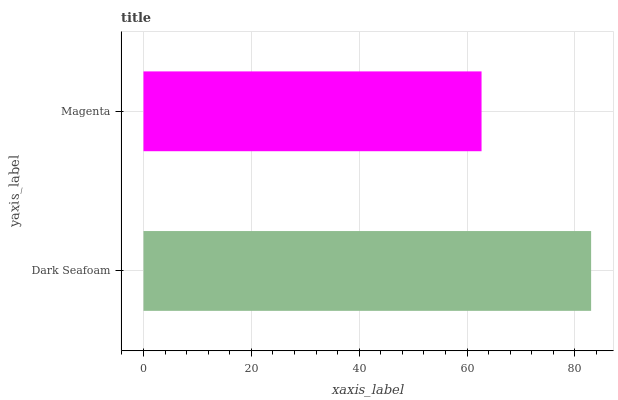Is Magenta the minimum?
Answer yes or no. Yes. Is Dark Seafoam the maximum?
Answer yes or no. Yes. Is Magenta the maximum?
Answer yes or no. No. Is Dark Seafoam greater than Magenta?
Answer yes or no. Yes. Is Magenta less than Dark Seafoam?
Answer yes or no. Yes. Is Magenta greater than Dark Seafoam?
Answer yes or no. No. Is Dark Seafoam less than Magenta?
Answer yes or no. No. Is Dark Seafoam the high median?
Answer yes or no. Yes. Is Magenta the low median?
Answer yes or no. Yes. Is Magenta the high median?
Answer yes or no. No. Is Dark Seafoam the low median?
Answer yes or no. No. 